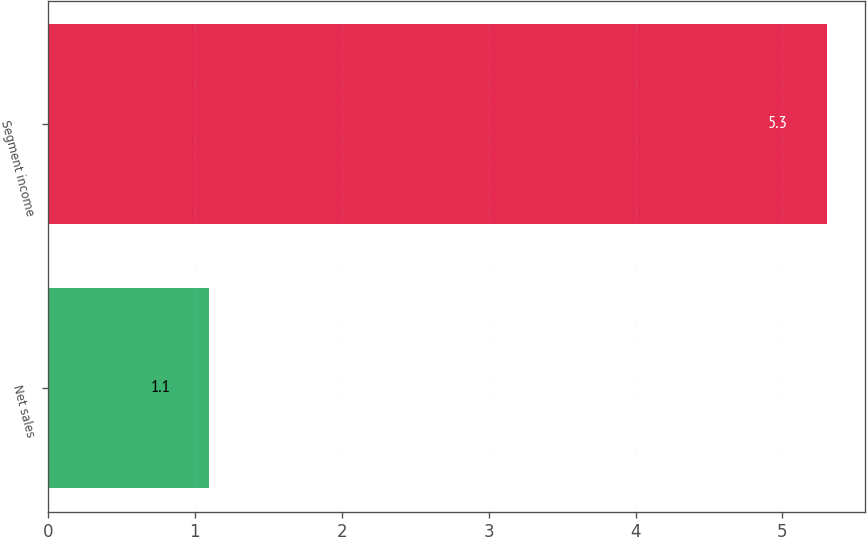Convert chart. <chart><loc_0><loc_0><loc_500><loc_500><bar_chart><fcel>Net sales<fcel>Segment income<nl><fcel>1.1<fcel>5.3<nl></chart> 